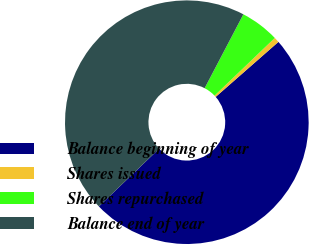Convert chart. <chart><loc_0><loc_0><loc_500><loc_500><pie_chart><fcel>Balance beginning of year<fcel>Shares issued<fcel>Shares repurchased<fcel>Balance end of year<nl><fcel>49.3%<fcel>0.7%<fcel>5.16%<fcel>44.84%<nl></chart> 